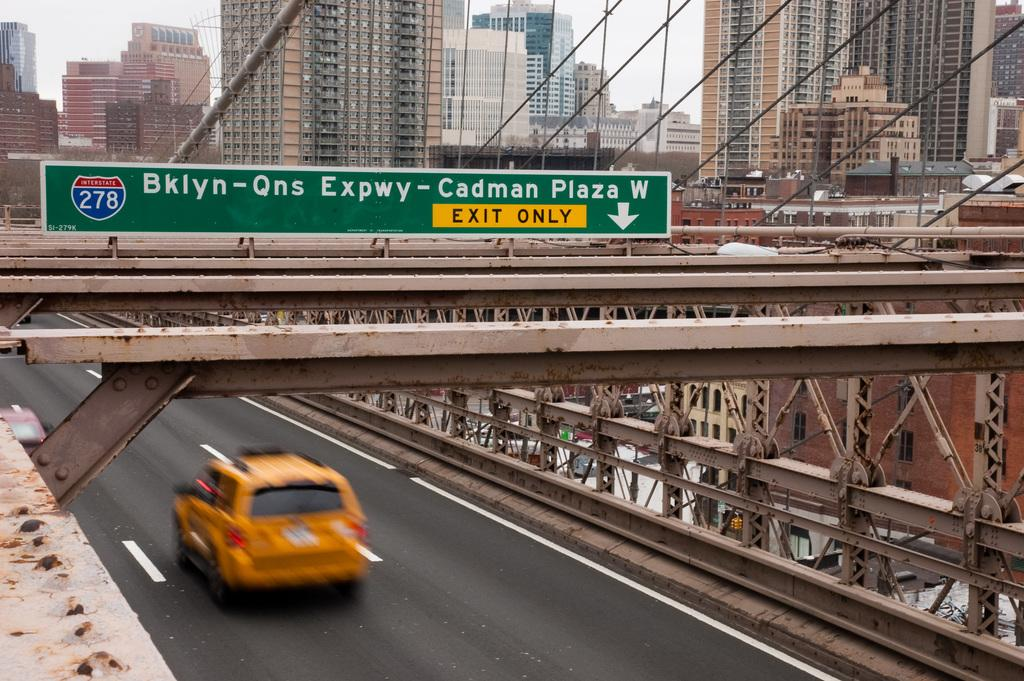What is on the bridge in the image? There is a car on the bridge in the image. What can be seen in the background of the image? Buildings are visible at the top of the image. What is located in the middle of the image? There is a board in the middle of the image. What type of mind can be seen floating above the car in the image? There is no mind present in the image; it only features a car on a bridge, buildings in the background, and a board in the middle. 